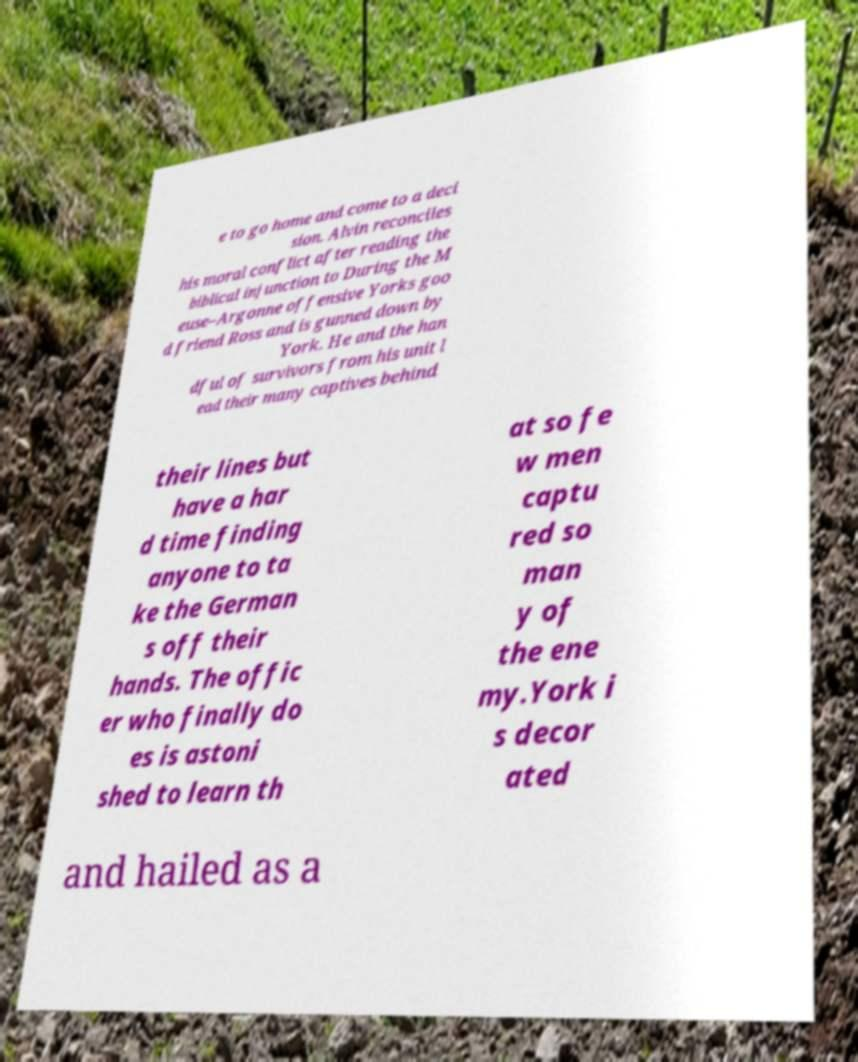Please read and relay the text visible in this image. What does it say? e to go home and come to a deci sion. Alvin reconciles his moral conflict after reading the biblical injunction to During the M euse–Argonne offensive Yorks goo d friend Ross and is gunned down by York. He and the han dful of survivors from his unit l ead their many captives behind their lines but have a har d time finding anyone to ta ke the German s off their hands. The offic er who finally do es is astoni shed to learn th at so fe w men captu red so man y of the ene my.York i s decor ated and hailed as a 